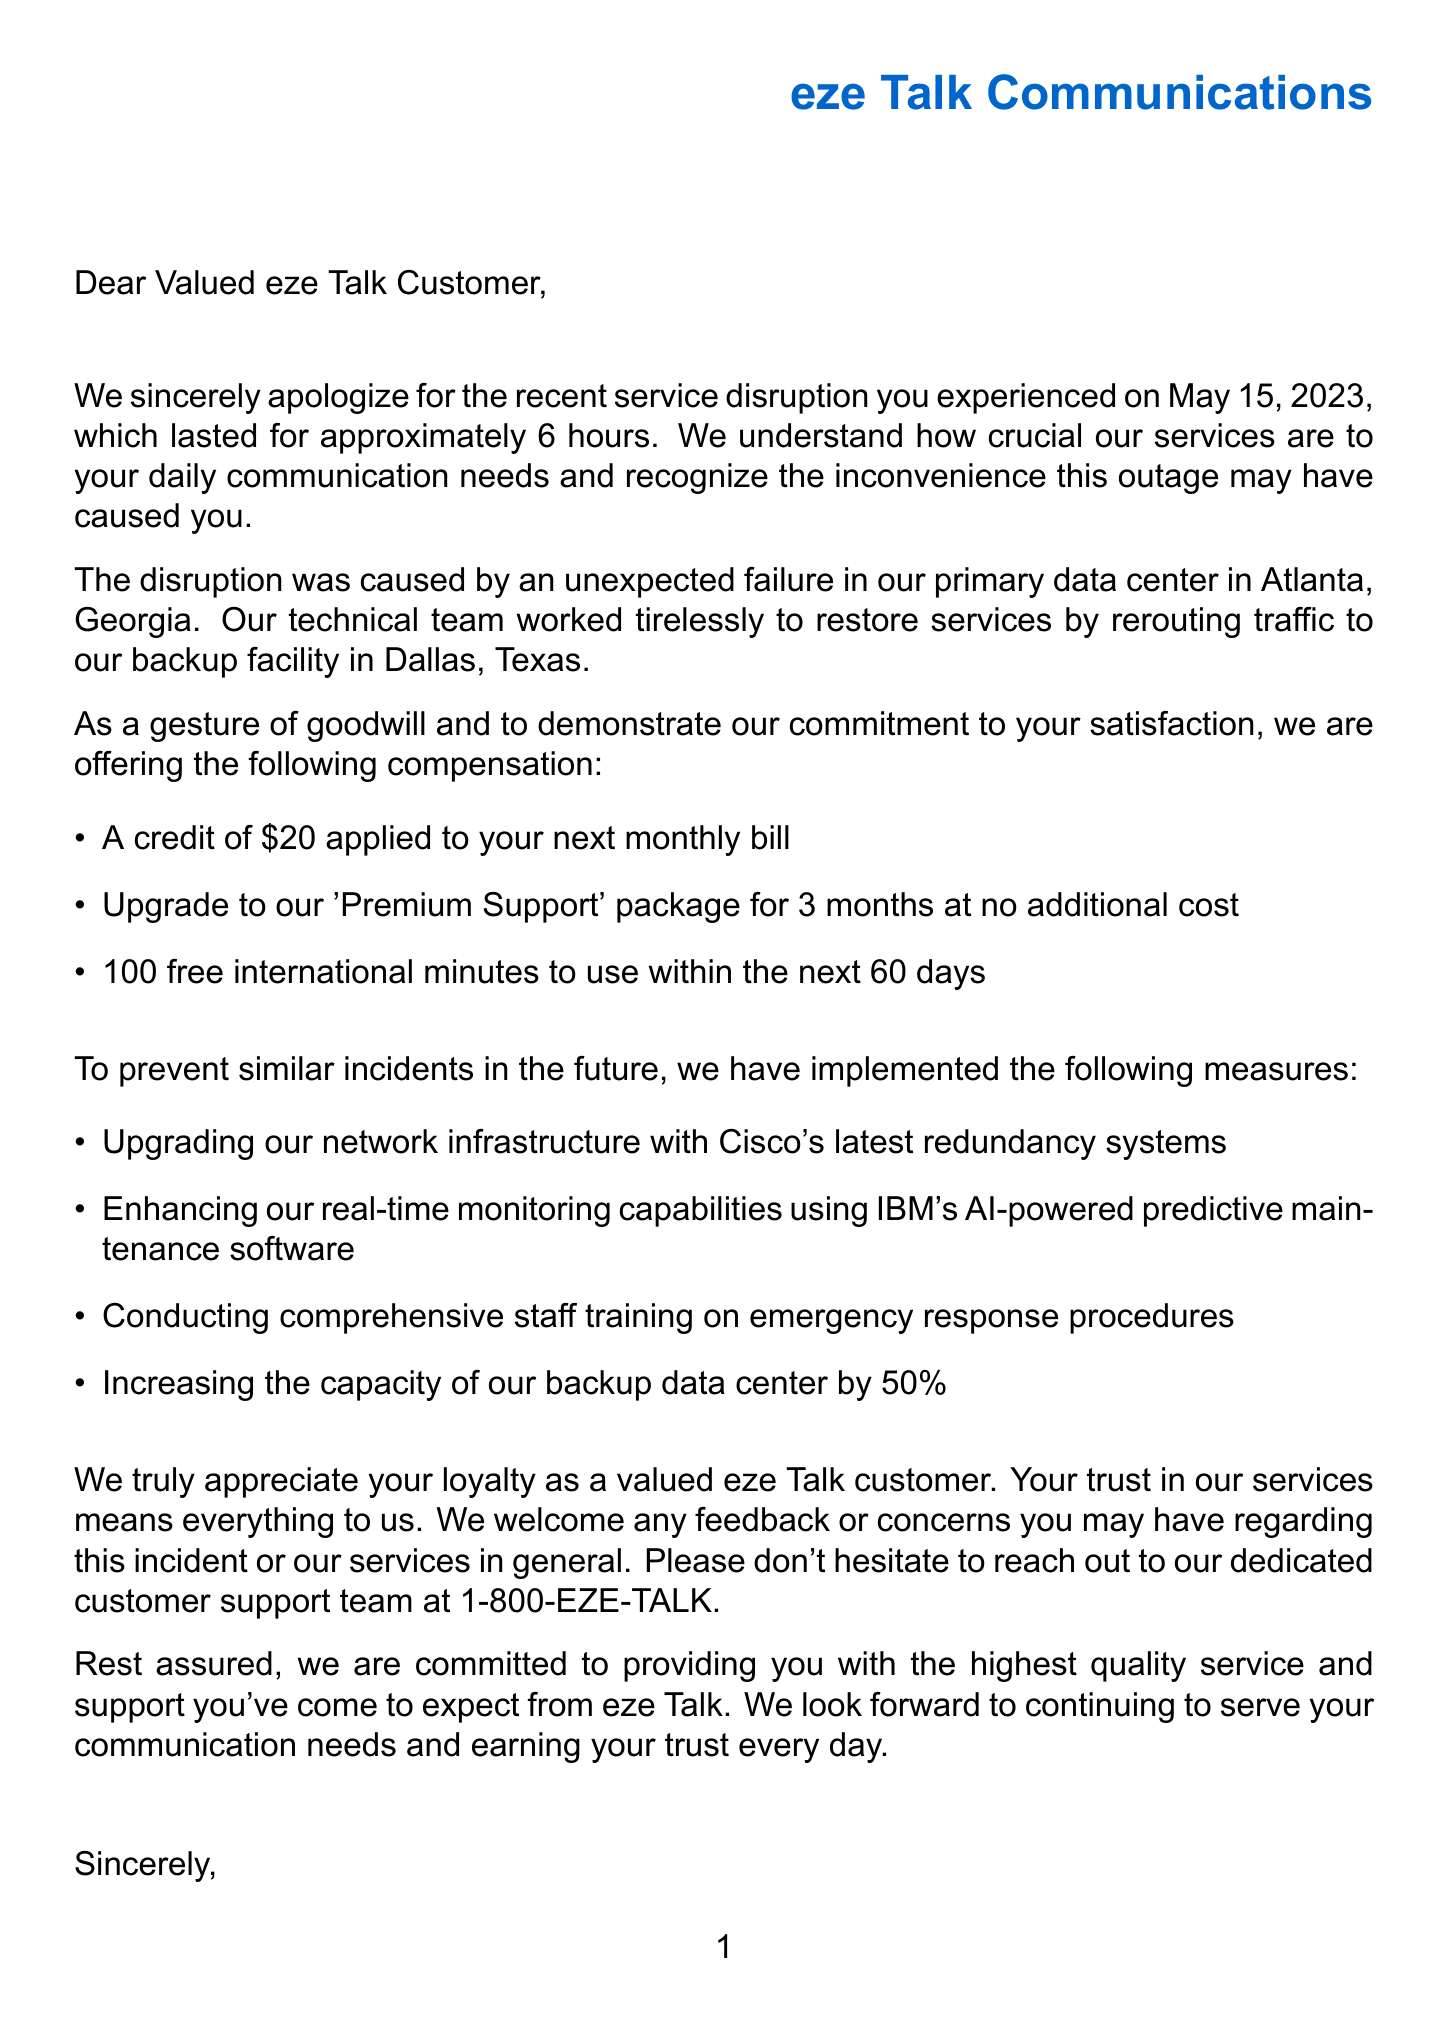what date did the service disruption occur? The document states that the service disruption occurred on May 15, 2023.
Answer: May 15, 2023 how long did the service disruption last? The document mentions that the service disruption lasted for approximately 6 hours.
Answer: approximately 6 hours what compensation is offered to customers? The document outlines various compensation details such as a $20 credit, premium support upgrade, and free international minutes.
Answer: A credit of $20, upgrade to 'Premium Support' for 3 months, 100 free international minutes how many steps were taken to prevent future incidents? The document lists four prevention measures implemented to avert future incidents.
Answer: 4 who is the sender of the letter? The document identifies Sarah Johnson as the sender of the letter.
Answer: Sarah Johnson what was the cause of the service disruption? The letter explains that the disruption was caused by an unexpected failure in the primary data center in Atlanta, Georgia.
Answer: unexpected failure in our primary data center in Atlanta, Georgia what type of support is provided for free for 3 months? The document specifies that customers will receive an upgrade to the 'Premium Support' package for three months at no additional cost.
Answer: 'Premium Support' how is customer feedback encouraged? The document invites customers to reach out to the dedicated customer support team for feedback or concerns.
Answer: reach out to our dedicated customer support team at 1-800-EZE-TALK 